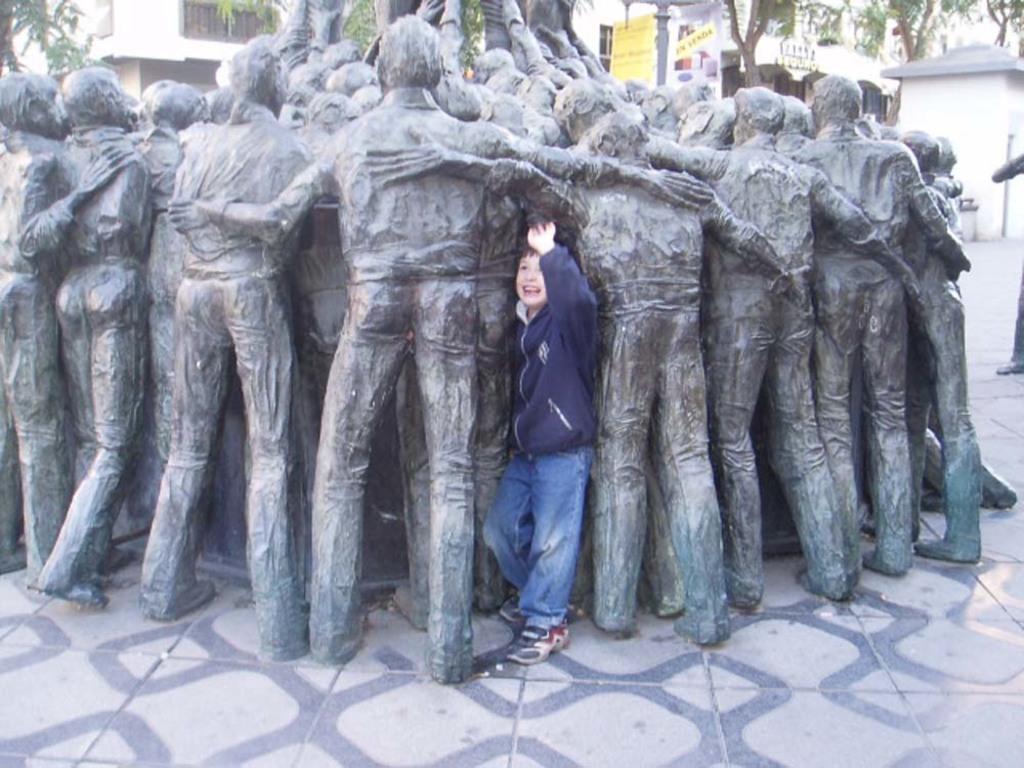Please provide a concise description of this image. In this picture we can see a boy wore a jacket, shoes and standing on the floor, statue, buildings, posters and in the background we can see trees. 